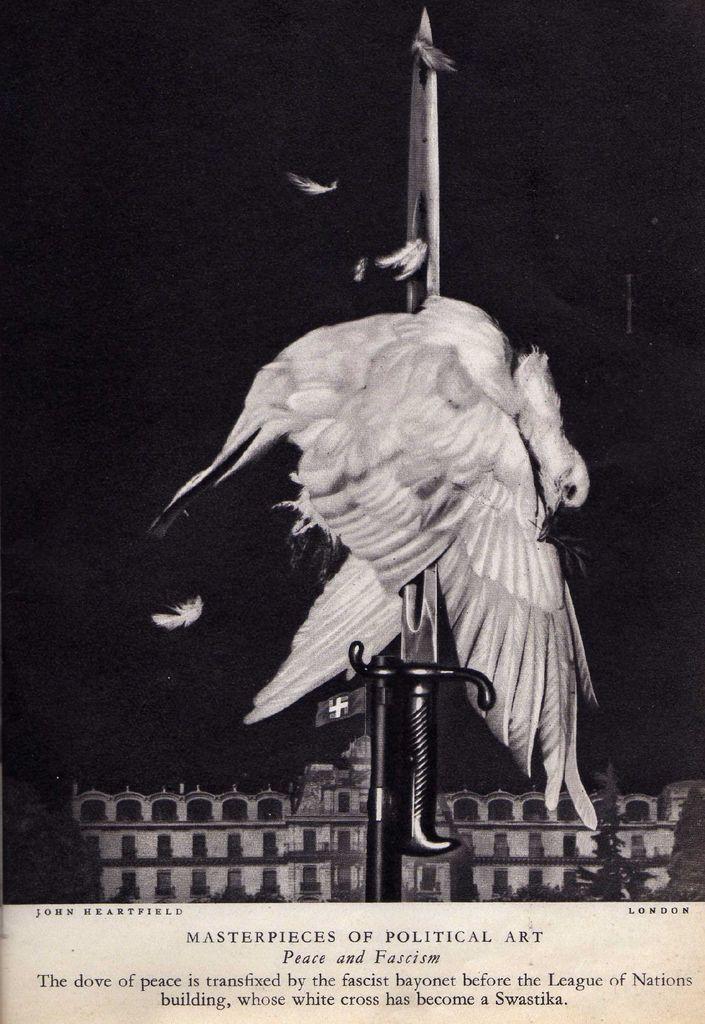What is the bird in the picture?
Make the answer very short. Dove. Master piece of political art?
Offer a very short reply. Yes. 